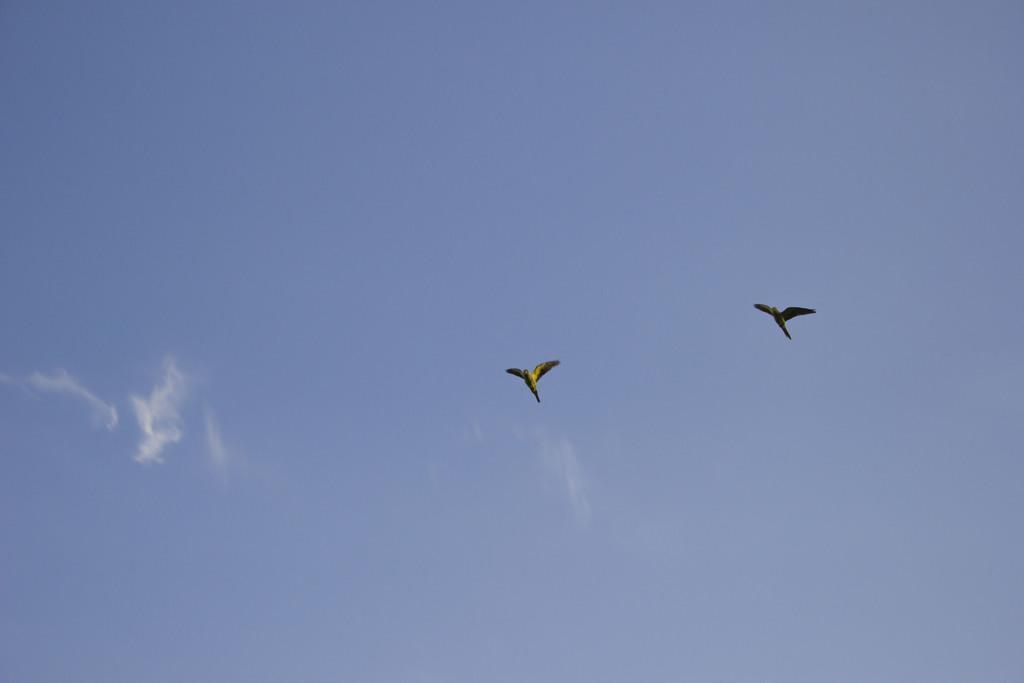Please provide a concise description of this image. In this picture we can see two birds flying and in the background we can see sky with clouds. 